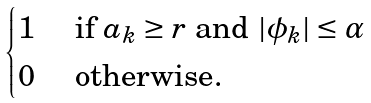<formula> <loc_0><loc_0><loc_500><loc_500>\begin{cases} 1 & \text { if } a _ { k } \geq r \text { and } | \phi _ { k } | \leq \alpha \\ 0 & \text { otherwise} . \end{cases}</formula> 